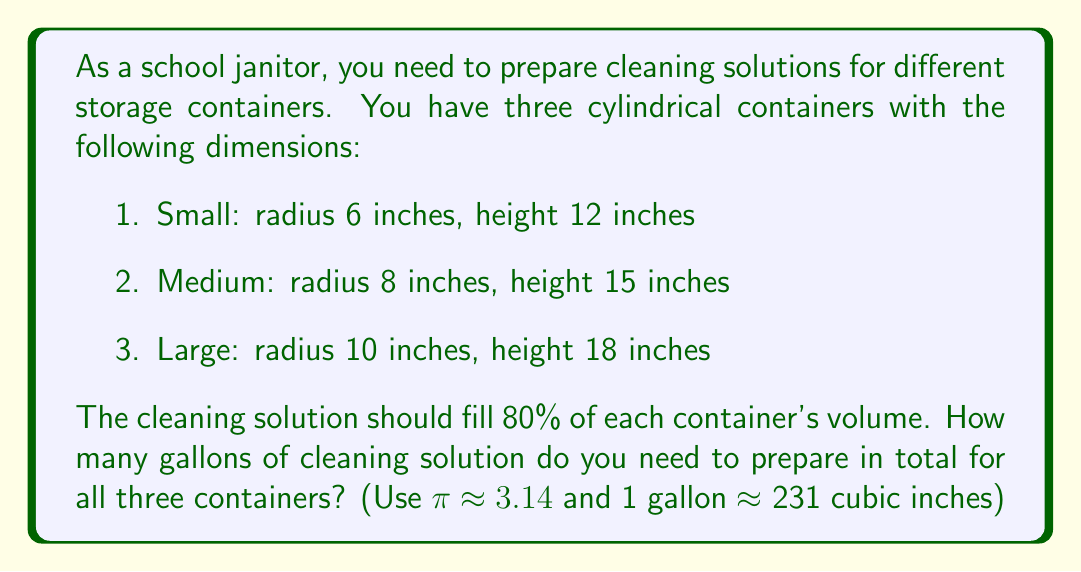Provide a solution to this math problem. Let's approach this problem step-by-step:

1. Calculate the volume of each cylindrical container using the formula $V = \pi r^2 h$:

   Small: $V_s = \pi (6^2)(12) = 3.14 \times 36 \times 12 = 1,357.92$ cubic inches
   Medium: $V_m = \pi (8^2)(15) = 3.14 \times 64 \times 15 = 3,016.32$ cubic inches
   Large: $V_l = \pi (10^2)(18) = 3.14 \times 100 \times 18 = 5,652$ cubic inches

2. Calculate 80% of each container's volume:

   Small: $0.8 \times 1,357.92 = 1,086.34$ cubic inches
   Medium: $0.8 \times 3,016.32 = 2,413.06$ cubic inches
   Large: $0.8 \times 5,652 = 4,521.6$ cubic inches

3. Sum up the volumes:

   Total volume = $1,086.34 + 2,413.06 + 4,521.6 = 8,021$ cubic inches

4. Convert cubic inches to gallons:

   $\frac{8,021 \text{ cubic inches}}{231 \text{ cubic inches/gallon}} \approx 34.72$ gallons

Therefore, you need approximately 34.72 gallons of cleaning solution in total.
Answer: 34.72 gallons 